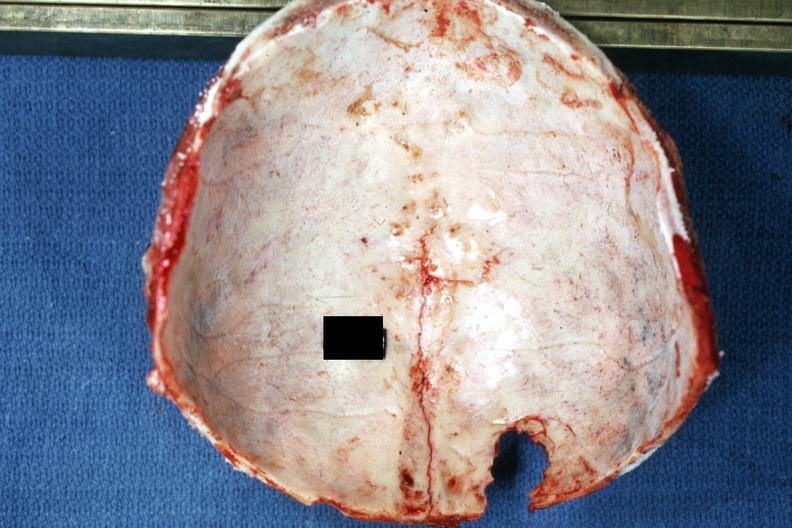s exact cause present?
Answer the question using a single word or phrase. No 